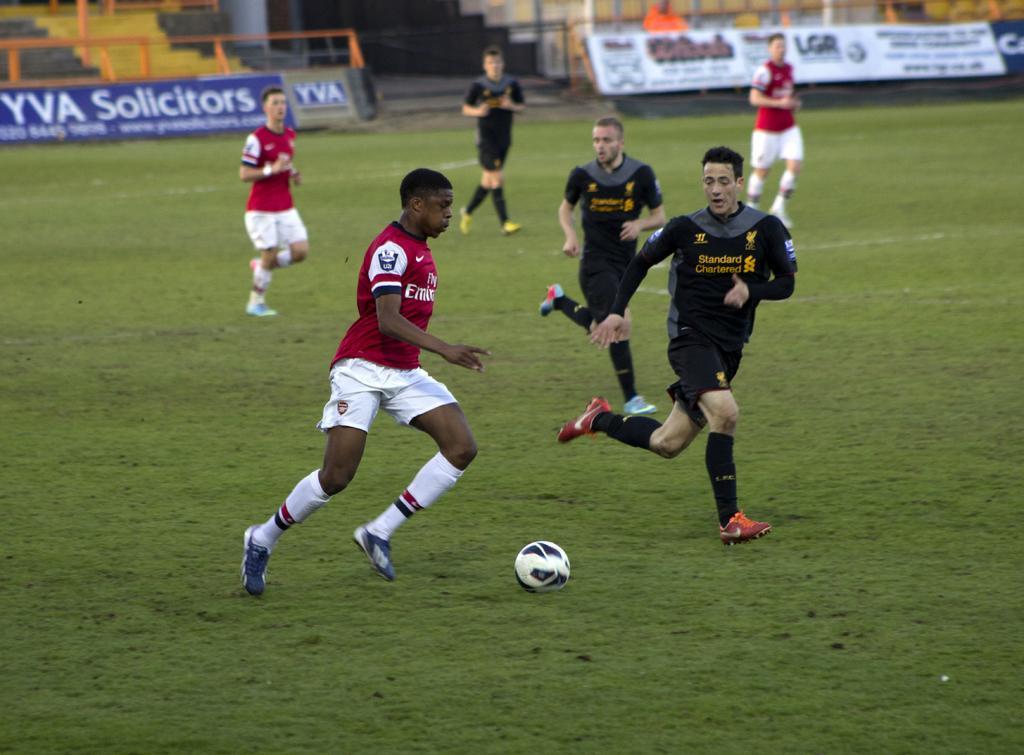In one or two sentences, can you explain what this image depicts? In this image we can see few people running. On the ground there is grass and a ball. In the background there are banners, steps. On the banners something is written. 